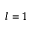Convert formula to latex. <formula><loc_0><loc_0><loc_500><loc_500>l = 1</formula> 